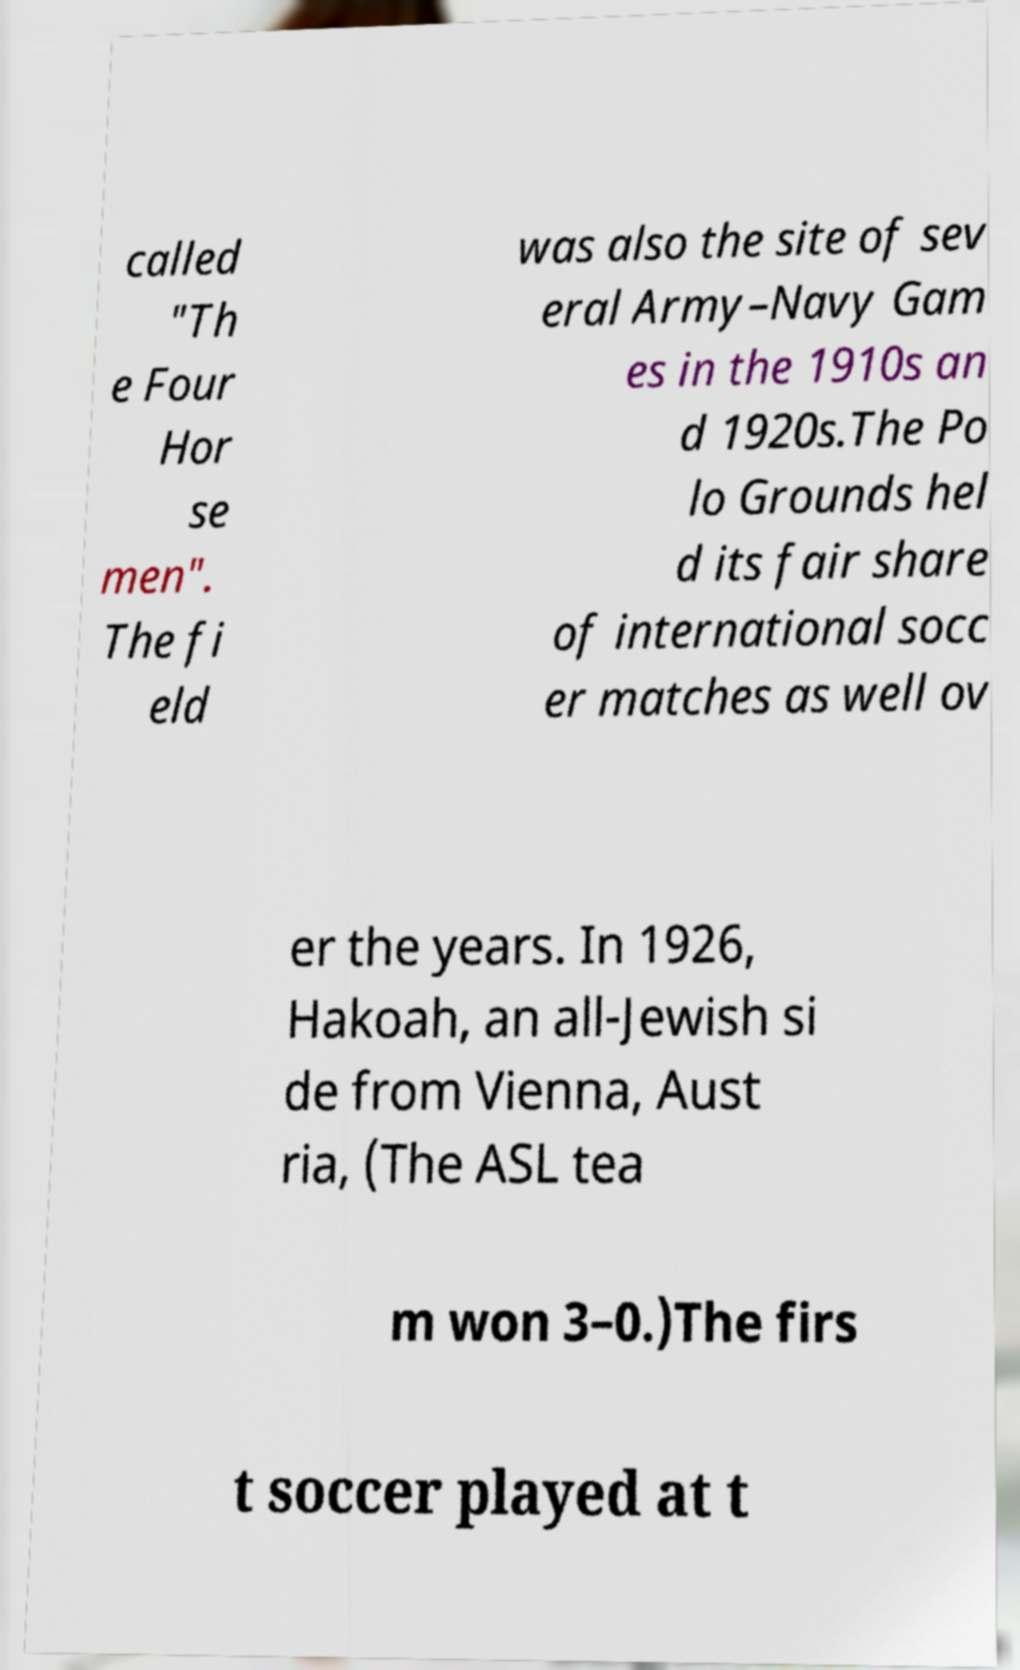Can you tell more about the history of Polo Grounds and its significance in sports? Certainly! The Polo Grounds was a historic sports stadium located in Upper Manhattan, New York. It was primarily known as the home of the New York Giants baseball team. The stadium hosted many notable events, including MLB games, boxing matches, and football games, featuring teams like the New York Jets. Its unique, horseshoe shape made it a memorable venue in American sports history. 